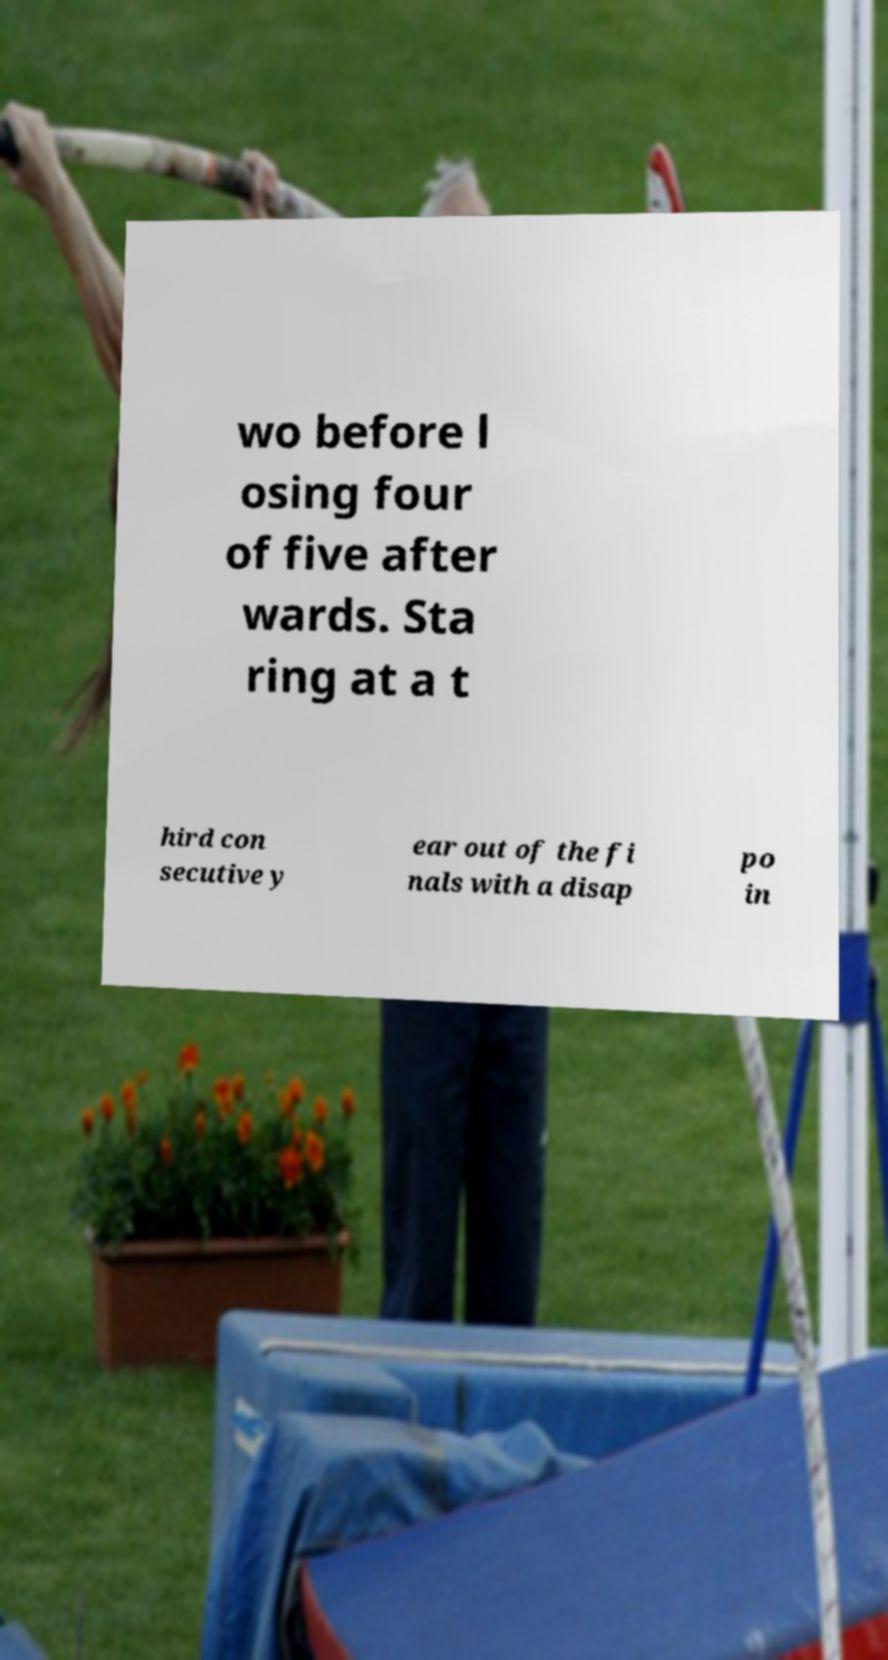Please identify and transcribe the text found in this image. wo before l osing four of five after wards. Sta ring at a t hird con secutive y ear out of the fi nals with a disap po in 